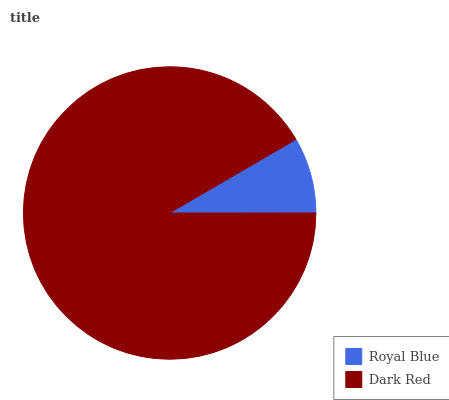Is Royal Blue the minimum?
Answer yes or no. Yes. Is Dark Red the maximum?
Answer yes or no. Yes. Is Dark Red the minimum?
Answer yes or no. No. Is Dark Red greater than Royal Blue?
Answer yes or no. Yes. Is Royal Blue less than Dark Red?
Answer yes or no. Yes. Is Royal Blue greater than Dark Red?
Answer yes or no. No. Is Dark Red less than Royal Blue?
Answer yes or no. No. Is Dark Red the high median?
Answer yes or no. Yes. Is Royal Blue the low median?
Answer yes or no. Yes. Is Royal Blue the high median?
Answer yes or no. No. Is Dark Red the low median?
Answer yes or no. No. 